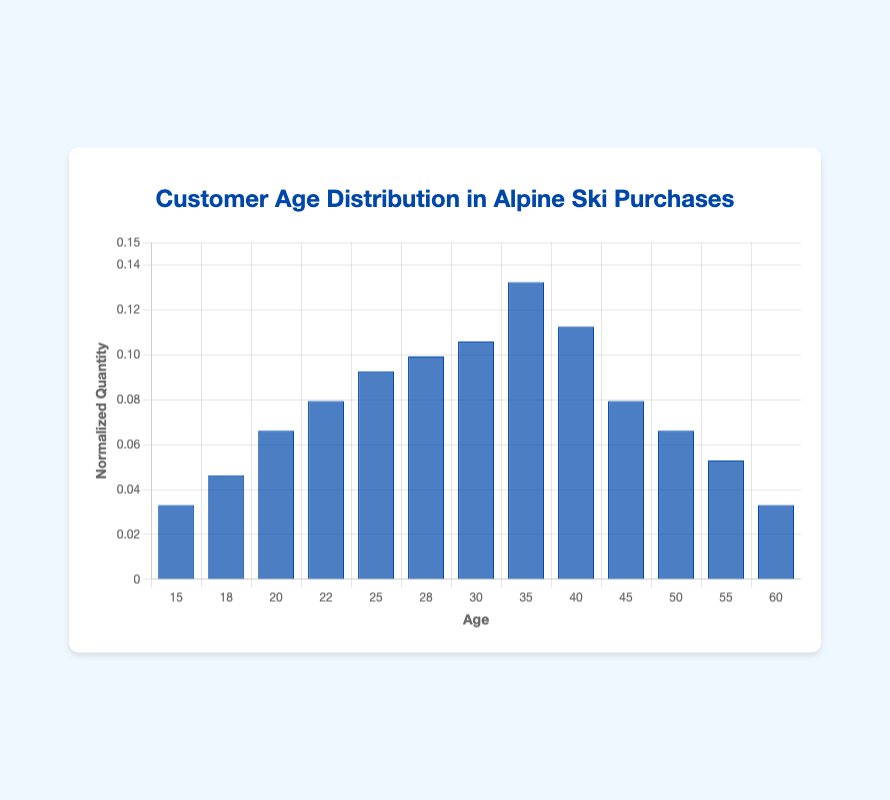What is the title of the figure? The title is located at the top center of the figure, written in a larger, distinctive font. It introduces the audience to the context of the data displayed.
Answer: Customer Age Distribution in Alpine Ski Purchases What is the age range represented on the x-axis? The x-axis shows the age groups from the lowest to the highest age recorded. By looking at these labels, you can determine that the ages range from 15 to 60 years old.
Answer: 15 to 60 years old Which age group has the highest normalized quantity of alpine ski purchases? By comparing the heights of the bars in the histogram, the age group with the tallest bar has the highest normalized quantity. The highest bar corresponds to the age 35 group.
Answer: 35 years old How does the normalized quantity for age 25 compare to that for age 55? Find the bars corresponding to ages 25 and 55 and compare their heights. The bar for age 25 is higher than that for age 55, indicating a greater normalized quantity.
Answer: Higher for age 25 What's the sum of normalized quantities for ages 45, 50, and 55? Add the normalized quantities for these ages from the height of the respective bars: (45 = 0.08) + (50 = 0.067) + (55 = 0.053).
Answer: 0.20 What is the median age group in terms of normalized quantity? Order the age groups by their normalized quantities and find the middle value(s). The median falls around age 30.
Answer: Age 30 How much higher is the normalized quantity for age 35 compared to age 15? Calculate the difference between the normalized quantities for ages 35 and 15. Subtract the height of the bar at age 15 from the height at age 35.
Answer: Approximately 0.119 What trend can you observe from ages 15 to 35 and beyond 35? From ages 15 to 35, there is a general increase in the normalized quantity, peaking at 35. Beyond 35, the normalized quantity starts to decline. This is evident from the progression of bar heights.
Answer: Increase then decrease Is there an age group whose bar height is exactly half that of the age group with the highest normalized quantity? Identify the bar height for age 35 (highest) and check for another age group with a bar height that is half of this value. Age 18's bar height is not exactly but close.
Answer: No exact match 